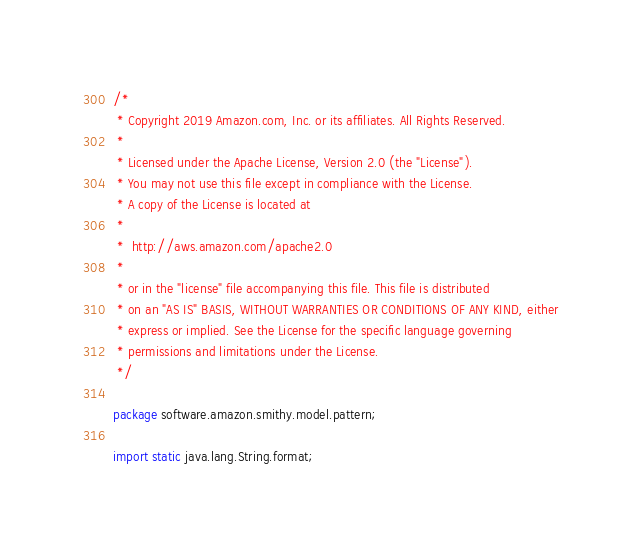Convert code to text. <code><loc_0><loc_0><loc_500><loc_500><_Java_>/*
 * Copyright 2019 Amazon.com, Inc. or its affiliates. All Rights Reserved.
 *
 * Licensed under the Apache License, Version 2.0 (the "License").
 * You may not use this file except in compliance with the License.
 * A copy of the License is located at
 *
 *  http://aws.amazon.com/apache2.0
 *
 * or in the "license" file accompanying this file. This file is distributed
 * on an "AS IS" BASIS, WITHOUT WARRANTIES OR CONDITIONS OF ANY KIND, either
 * express or implied. See the License for the specific language governing
 * permissions and limitations under the License.
 */

package software.amazon.smithy.model.pattern;

import static java.lang.String.format;
</code> 